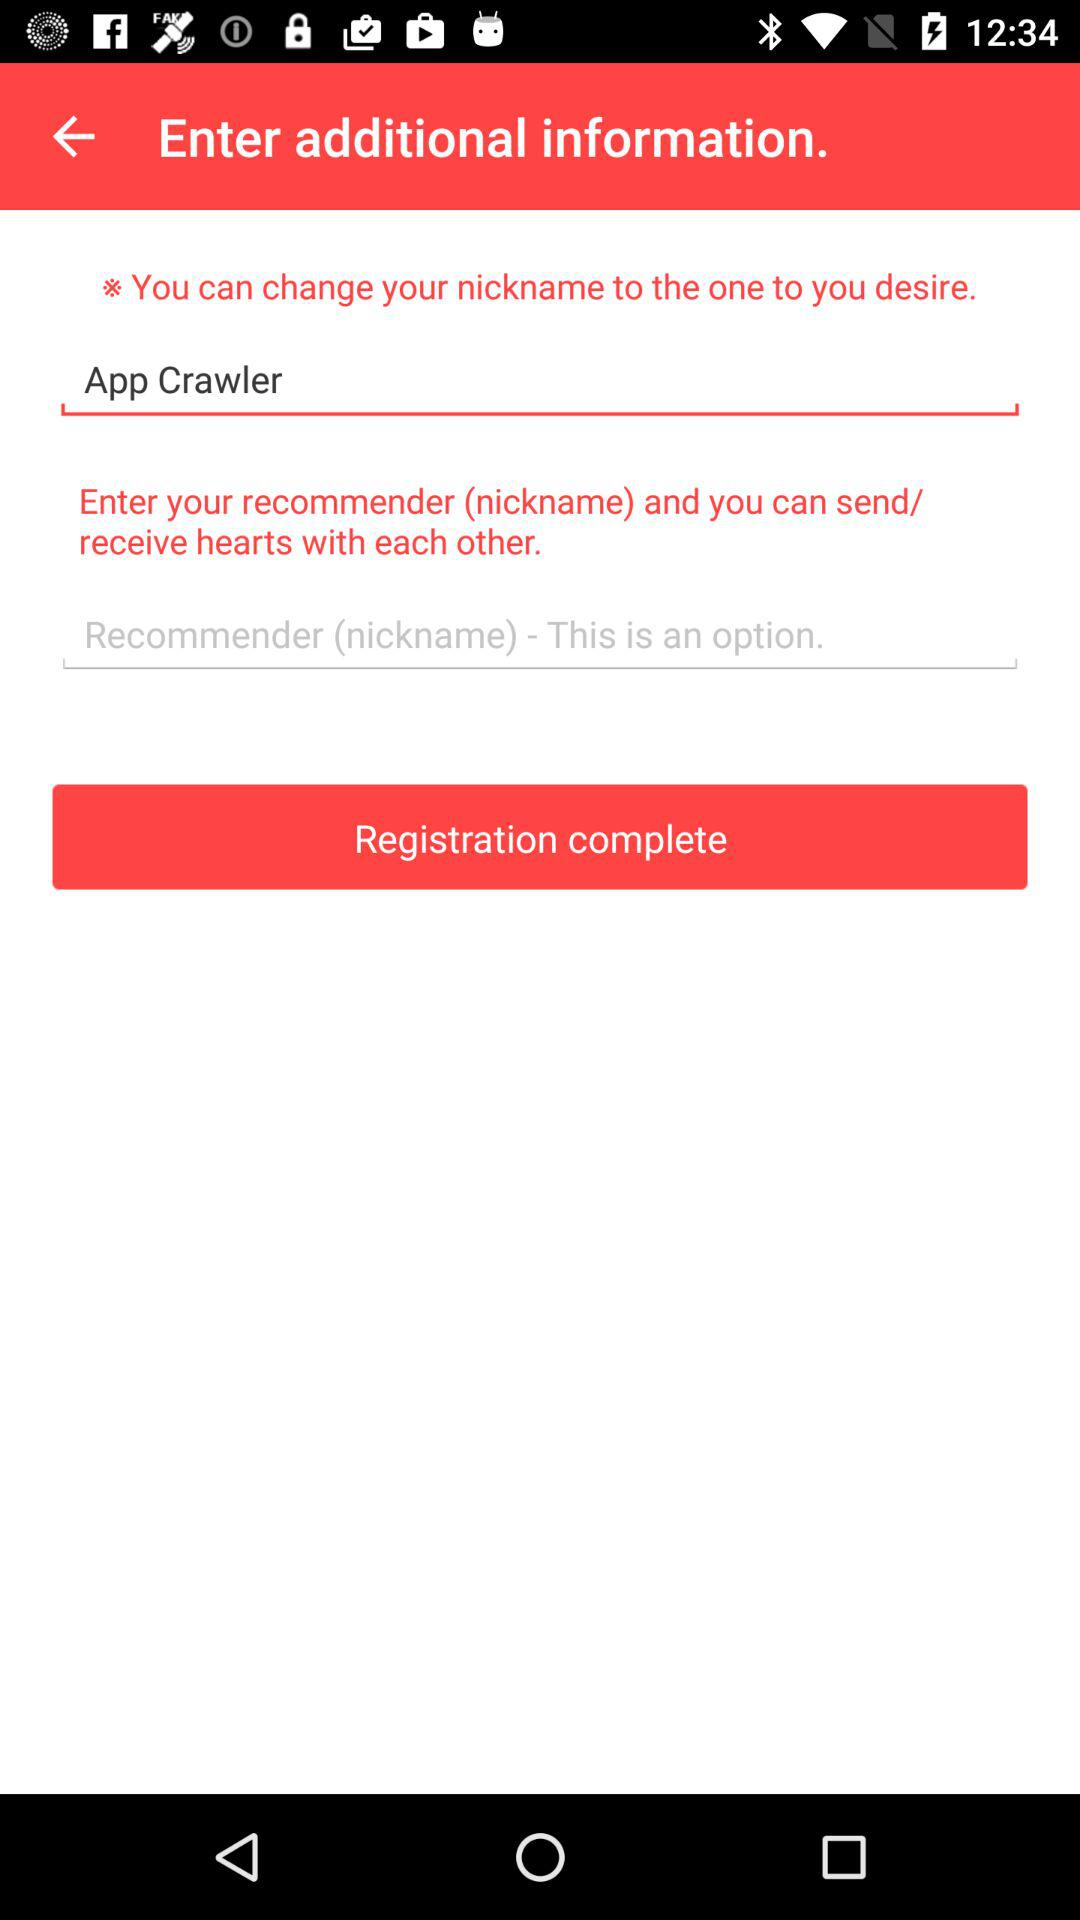What is the entered nickname that is desired? The entered nickname that is desired is "App Crawler". 